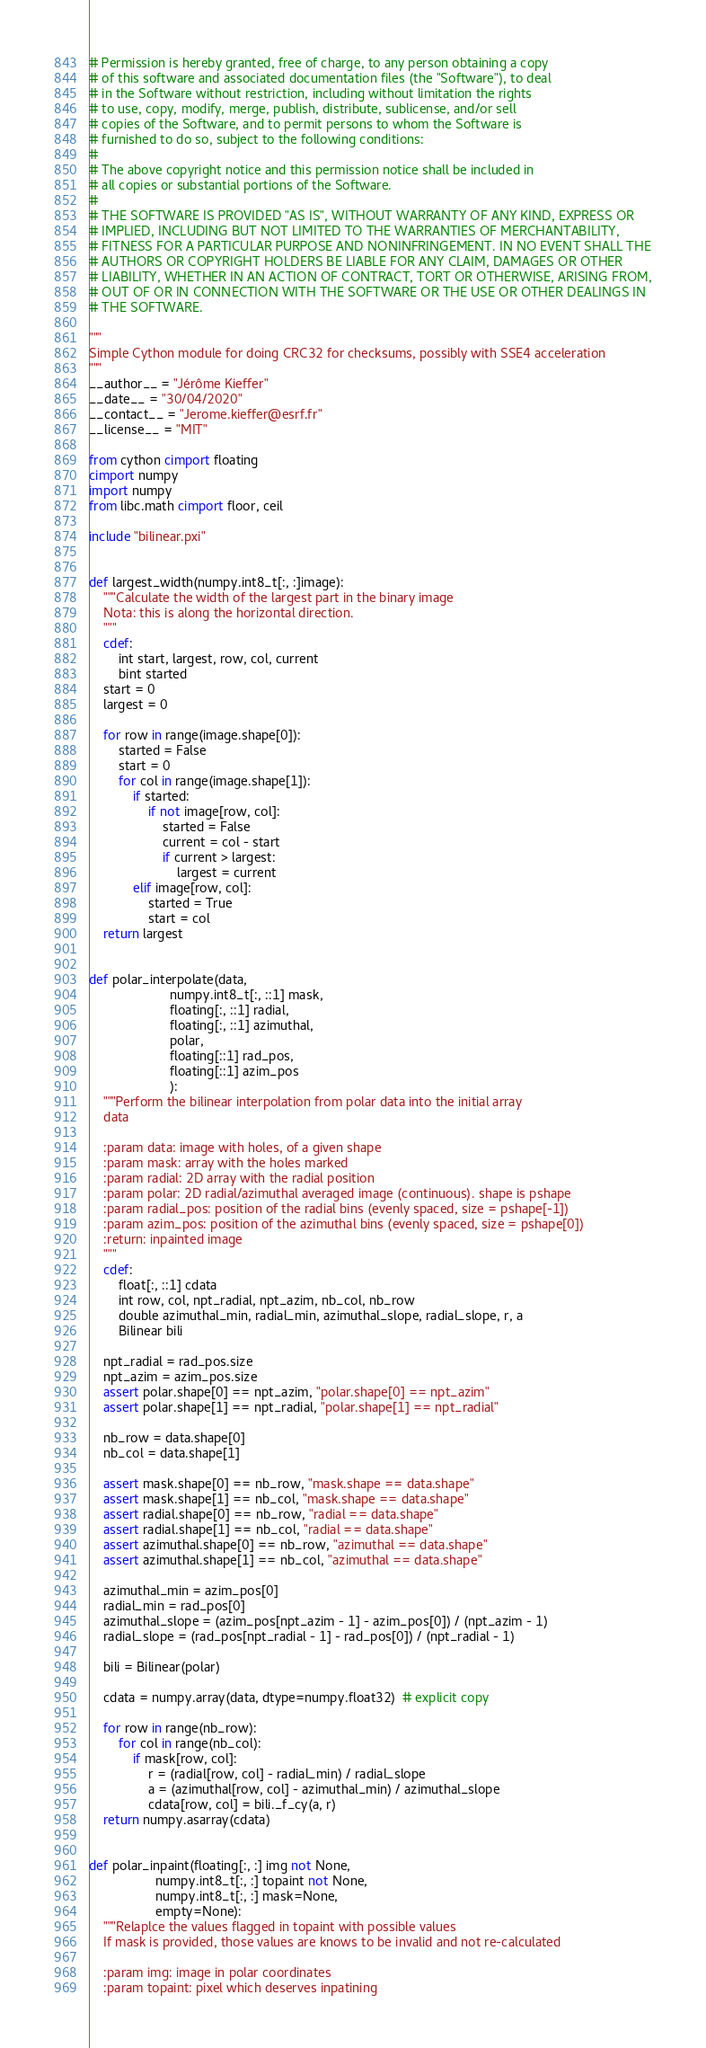<code> <loc_0><loc_0><loc_500><loc_500><_Cython_># Permission is hereby granted, free of charge, to any person obtaining a copy
# of this software and associated documentation files (the "Software"), to deal
# in the Software without restriction, including without limitation the rights
# to use, copy, modify, merge, publish, distribute, sublicense, and/or sell
# copies of the Software, and to permit persons to whom the Software is
# furnished to do so, subject to the following conditions:
#
# The above copyright notice and this permission notice shall be included in
# all copies or substantial portions of the Software.
#
# THE SOFTWARE IS PROVIDED "AS IS", WITHOUT WARRANTY OF ANY KIND, EXPRESS OR
# IMPLIED, INCLUDING BUT NOT LIMITED TO THE WARRANTIES OF MERCHANTABILITY,
# FITNESS FOR A PARTICULAR PURPOSE AND NONINFRINGEMENT. IN NO EVENT SHALL THE
# AUTHORS OR COPYRIGHT HOLDERS BE LIABLE FOR ANY CLAIM, DAMAGES OR OTHER
# LIABILITY, WHETHER IN AN ACTION OF CONTRACT, TORT OR OTHERWISE, ARISING FROM,
# OUT OF OR IN CONNECTION WITH THE SOFTWARE OR THE USE OR OTHER DEALINGS IN
# THE SOFTWARE.

"""
Simple Cython module for doing CRC32 for checksums, possibly with SSE4 acceleration
"""
__author__ = "Jérôme Kieffer"
__date__ = "30/04/2020"
__contact__ = "Jerome.kieffer@esrf.fr"
__license__ = "MIT"

from cython cimport floating 
cimport numpy
import numpy
from libc.math cimport floor, ceil

include "bilinear.pxi"


def largest_width(numpy.int8_t[:, :]image):
    """Calculate the width of the largest part in the binary image
    Nota: this is along the horizontal direction.
    """
    cdef:
        int start, largest, row, col, current
        bint started
    start = 0
    largest = 0

    for row in range(image.shape[0]):
        started = False
        start = 0
        for col in range(image.shape[1]):
            if started:
                if not image[row, col]:
                    started = False
                    current = col - start
                    if current > largest:
                        largest = current
            elif image[row, col]:
                started = True
                start = col
    return largest


def polar_interpolate(data,
                      numpy.int8_t[:, ::1] mask,
                      floating[:, ::1] radial,
                      floating[:, ::1] azimuthal,
                      polar,
                      floating[::1] rad_pos,
                      floating[::1] azim_pos
                      ):
    """Perform the bilinear interpolation from polar data into the initial array
    data

    :param data: image with holes, of a given shape
    :param mask: array with the holes marked
    :param radial: 2D array with the radial position
    :param polar: 2D radial/azimuthal averaged image (continuous). shape is pshape
    :param radial_pos: position of the radial bins (evenly spaced, size = pshape[-1])
    :param azim_pos: position of the azimuthal bins (evenly spaced, size = pshape[0])
    :return: inpainted image
    """
    cdef:
        float[:, ::1] cdata
        int row, col, npt_radial, npt_azim, nb_col, nb_row
        double azimuthal_min, radial_min, azimuthal_slope, radial_slope, r, a
        Bilinear bili

    npt_radial = rad_pos.size
    npt_azim = azim_pos.size
    assert polar.shape[0] == npt_azim, "polar.shape[0] == npt_azim"
    assert polar.shape[1] == npt_radial, "polar.shape[1] == npt_radial"

    nb_row = data.shape[0]
    nb_col = data.shape[1]

    assert mask.shape[0] == nb_row, "mask.shape == data.shape"
    assert mask.shape[1] == nb_col, "mask.shape == data.shape"
    assert radial.shape[0] == nb_row, "radial == data.shape"
    assert radial.shape[1] == nb_col, "radial == data.shape"
    assert azimuthal.shape[0] == nb_row, "azimuthal == data.shape"
    assert azimuthal.shape[1] == nb_col, "azimuthal == data.shape"

    azimuthal_min = azim_pos[0]
    radial_min = rad_pos[0]
    azimuthal_slope = (azim_pos[npt_azim - 1] - azim_pos[0]) / (npt_azim - 1)
    radial_slope = (rad_pos[npt_radial - 1] - rad_pos[0]) / (npt_radial - 1)

    bili = Bilinear(polar)

    cdata = numpy.array(data, dtype=numpy.float32)  # explicit copy

    for row in range(nb_row):
        for col in range(nb_col):
            if mask[row, col]:
                r = (radial[row, col] - radial_min) / radial_slope
                a = (azimuthal[row, col] - azimuthal_min) / azimuthal_slope
                cdata[row, col] = bili._f_cy(a, r)
    return numpy.asarray(cdata)


def polar_inpaint(floating[:, :] img not None,
                  numpy.int8_t[:, :] topaint not None,
                  numpy.int8_t[:, :] mask=None,
                  empty=None):
    """Relaplce the values flagged in topaint with possible values
    If mask is provided, those values are knows to be invalid and not re-calculated

    :param img: image in polar coordinates
    :param topaint: pixel which deserves inpatining</code> 